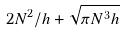<formula> <loc_0><loc_0><loc_500><loc_500>2 N ^ { 2 } / h + \sqrt { \pi N ^ { 3 } h }</formula> 